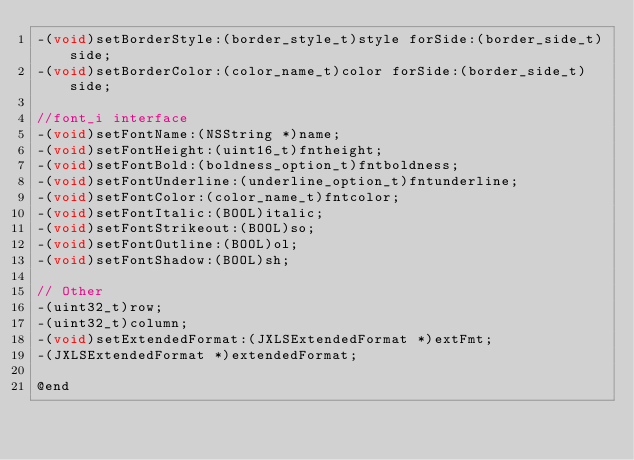<code> <loc_0><loc_0><loc_500><loc_500><_C_>-(void)setBorderStyle:(border_style_t)style forSide:(border_side_t)side;
-(void)setBorderColor:(color_name_t)color forSide:(border_side_t)side;

//font_i interface
-(void)setFontName:(NSString *)name;
-(void)setFontHeight:(uint16_t)fntheight;
-(void)setFontBold:(boldness_option_t)fntboldness;
-(void)setFontUnderline:(underline_option_t)fntunderline;
-(void)setFontColor:(color_name_t)fntcolor;
-(void)setFontItalic:(BOOL)italic;
-(void)setFontStrikeout:(BOOL)so;
-(void)setFontOutline:(BOOL)ol;
-(void)setFontShadow:(BOOL)sh;

// Other
-(uint32_t)row;
-(uint32_t)column;
-(void)setExtendedFormat:(JXLSExtendedFormat *)extFmt;
-(JXLSExtendedFormat *)extendedFormat;

@end
</code> 